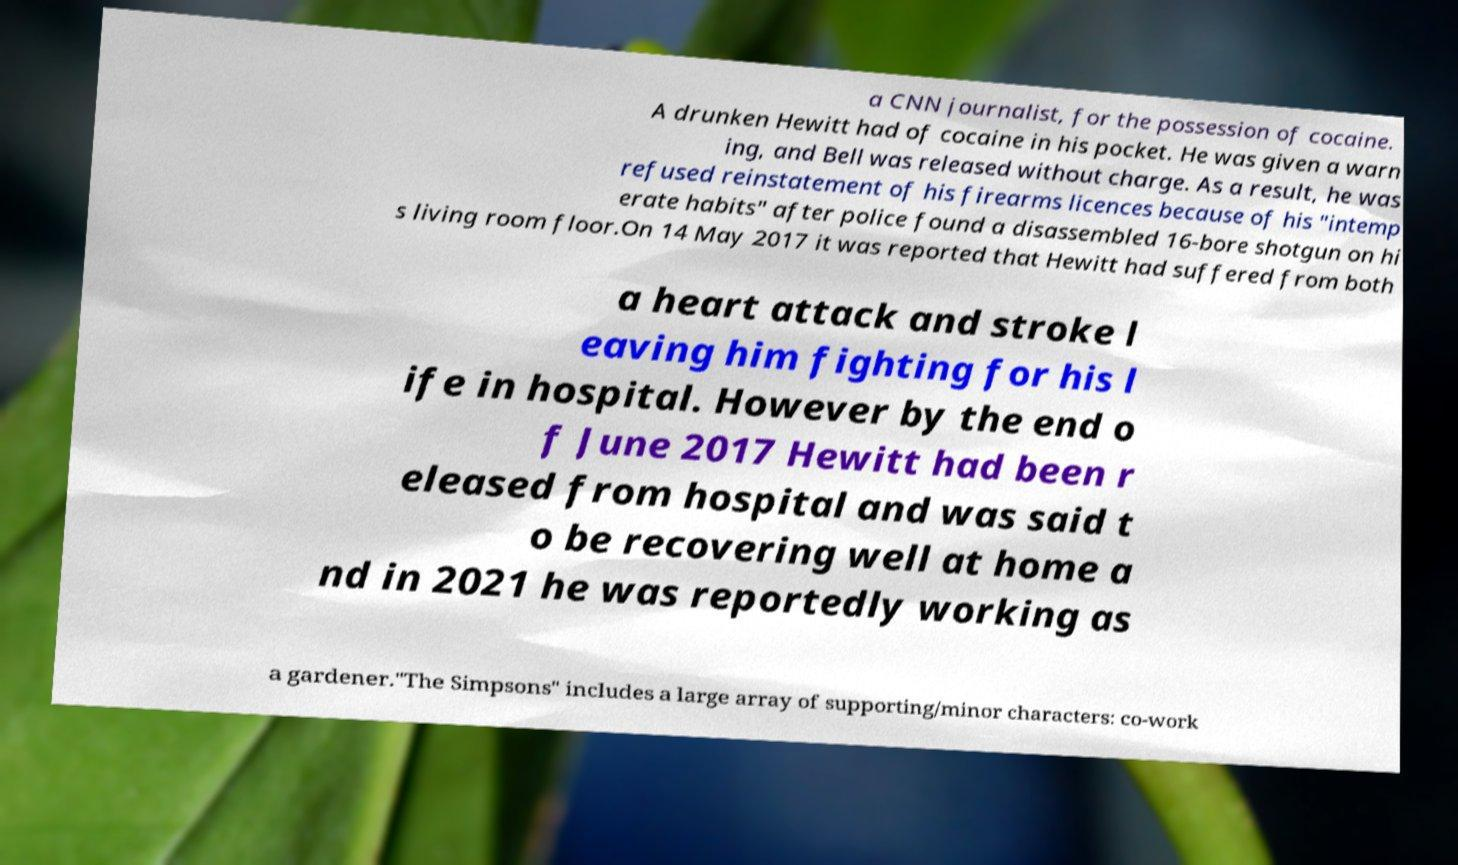There's text embedded in this image that I need extracted. Can you transcribe it verbatim? a CNN journalist, for the possession of cocaine. A drunken Hewitt had of cocaine in his pocket. He was given a warn ing, and Bell was released without charge. As a result, he was refused reinstatement of his firearms licences because of his "intemp erate habits" after police found a disassembled 16-bore shotgun on hi s living room floor.On 14 May 2017 it was reported that Hewitt had suffered from both a heart attack and stroke l eaving him fighting for his l ife in hospital. However by the end o f June 2017 Hewitt had been r eleased from hospital and was said t o be recovering well at home a nd in 2021 he was reportedly working as a gardener."The Simpsons" includes a large array of supporting/minor characters: co-work 